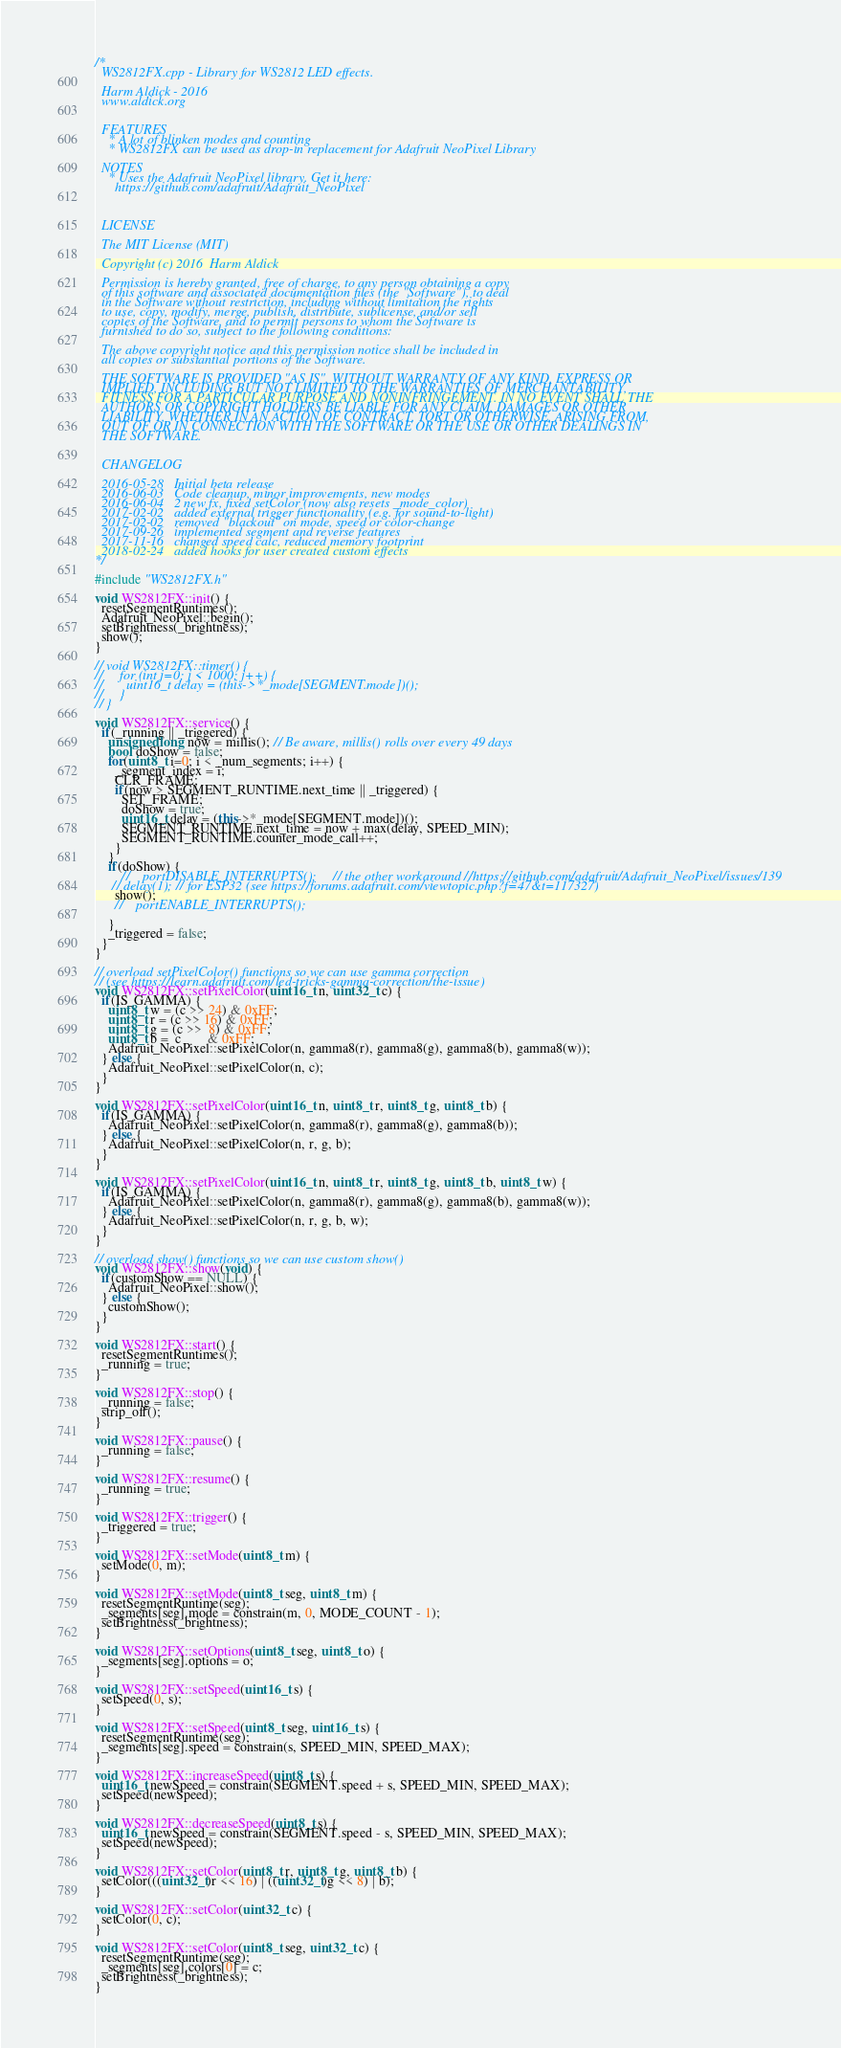<code> <loc_0><loc_0><loc_500><loc_500><_C++_>/*
  WS2812FX.cpp - Library for WS2812 LED effects.

  Harm Aldick - 2016
  www.aldick.org


  FEATURES
    * A lot of blinken modes and counting
    * WS2812FX can be used as drop-in replacement for Adafruit NeoPixel Library

  NOTES
    * Uses the Adafruit NeoPixel library. Get it here:
      https://github.com/adafruit/Adafruit_NeoPixel



  LICENSE

  The MIT License (MIT)

  Copyright (c) 2016  Harm Aldick

  Permission is hereby granted, free of charge, to any person obtaining a copy
  of this software and associated documentation files (the "Software"), to deal
  in the Software without restriction, including without limitation the rights
  to use, copy, modify, merge, publish, distribute, sublicense, and/or sell
  copies of the Software, and to permit persons to whom the Software is
  furnished to do so, subject to the following conditions:

  The above copyright notice and this permission notice shall be included in
  all copies or substantial portions of the Software.

  THE SOFTWARE IS PROVIDED "AS IS", WITHOUT WARRANTY OF ANY KIND, EXPRESS OR
  IMPLIED, INCLUDING BUT NOT LIMITED TO THE WARRANTIES OF MERCHANTABILITY,
  FITNESS FOR A PARTICULAR PURPOSE AND NONINFRINGEMENT. IN NO EVENT SHALL THE
  AUTHORS OR COPYRIGHT HOLDERS BE LIABLE FOR ANY CLAIM, DAMAGES OR OTHER
  LIABILITY, WHETHER IN AN ACTION OF CONTRACT, TORT OR OTHERWISE, ARISING FROM,
  OUT OF OR IN CONNECTION WITH THE SOFTWARE OR THE USE OR OTHER DEALINGS IN
  THE SOFTWARE.


  CHANGELOG

  2016-05-28   Initial beta release
  2016-06-03   Code cleanup, minor improvements, new modes
  2016-06-04   2 new fx, fixed setColor (now also resets _mode_color)
  2017-02-02   added external trigger functionality (e.g. for sound-to-light)
  2017-02-02   removed "blackout" on mode, speed or color-change
  2017-09-26   implemented segment and reverse features
  2017-11-16   changed speed calc, reduced memory footprint
  2018-02-24   added hooks for user created custom effects
*/

#include "WS2812FX.h"

void WS2812FX::init() {
  resetSegmentRuntimes();
  Adafruit_NeoPixel::begin();
  setBrightness(_brightness);
  show();
}

// void WS2812FX::timer() {
//     for (int j=0; j < 1000; j++) {
//       uint16_t delay = (this->*_mode[SEGMENT.mode])();
//     }
// }

void WS2812FX::service() {
  if(_running || _triggered) {
    unsigned long now = millis(); // Be aware, millis() rolls over every 49 days
    bool doShow = false;
    for(uint8_t i=0; i < _num_segments; i++) {
      _segment_index = i;
      CLR_FRAME;
      if(now > SEGMENT_RUNTIME.next_time || _triggered) {
        SET_FRAME;
        doShow = true;
        uint16_t delay = (this->*_mode[SEGMENT.mode])();
        SEGMENT_RUNTIME.next_time = now + max(delay, SPEED_MIN);
        SEGMENT_RUNTIME.counter_mode_call++;
      }
    }
    if(doShow) {
		//    portDISABLE_INTERRUPTS();     // the other workaround //https://github.com/adafruit/Adafruit_NeoPixel/issues/139
     // delay(1); // for ESP32 (see https://forums.adafruit.com/viewtopic.php?f=47&t=117327)
      show();
	  //    portENABLE_INTERRUPTS();
    
    }
    _triggered = false;
  }
}

// overload setPixelColor() functions so we can use gamma correction
// (see https://learn.adafruit.com/led-tricks-gamma-correction/the-issue)
void WS2812FX::setPixelColor(uint16_t n, uint32_t c) {
  if(IS_GAMMA) {
    uint8_t w = (c >> 24) & 0xFF;
    uint8_t r = (c >> 16) & 0xFF;
    uint8_t g = (c >>  8) & 0xFF;
    uint8_t b =  c        & 0xFF;
    Adafruit_NeoPixel::setPixelColor(n, gamma8(r), gamma8(g), gamma8(b), gamma8(w));
  } else {
    Adafruit_NeoPixel::setPixelColor(n, c);
  }
}

void WS2812FX::setPixelColor(uint16_t n, uint8_t r, uint8_t g, uint8_t b) {
  if(IS_GAMMA) {
    Adafruit_NeoPixel::setPixelColor(n, gamma8(r), gamma8(g), gamma8(b));
  } else {
    Adafruit_NeoPixel::setPixelColor(n, r, g, b);
  }
}

void WS2812FX::setPixelColor(uint16_t n, uint8_t r, uint8_t g, uint8_t b, uint8_t w) {
  if(IS_GAMMA) {
    Adafruit_NeoPixel::setPixelColor(n, gamma8(r), gamma8(g), gamma8(b), gamma8(w));
  } else {
    Adafruit_NeoPixel::setPixelColor(n, r, g, b, w);
  }
}

// overload show() functions so we can use custom show()
void WS2812FX::show(void) {
  if(customShow == NULL) {
    Adafruit_NeoPixel::show();
  } else {
    customShow();
  }
}

void WS2812FX::start() {
  resetSegmentRuntimes();
  _running = true;
}

void WS2812FX::stop() {
  _running = false;
  strip_off();
}

void WS2812FX::pause() {
  _running = false;
}

void WS2812FX::resume() {
  _running = true;
}

void WS2812FX::trigger() {
  _triggered = true;
}

void WS2812FX::setMode(uint8_t m) {
  setMode(0, m);
}

void WS2812FX::setMode(uint8_t seg, uint8_t m) {
  resetSegmentRuntime(seg);
  _segments[seg].mode = constrain(m, 0, MODE_COUNT - 1);
  setBrightness(_brightness);
}

void WS2812FX::setOptions(uint8_t seg, uint8_t o) {
  _segments[seg].options = o;
}

void WS2812FX::setSpeed(uint16_t s) {
  setSpeed(0, s);
}

void WS2812FX::setSpeed(uint8_t seg, uint16_t s) {
  resetSegmentRuntime(seg);
  _segments[seg].speed = constrain(s, SPEED_MIN, SPEED_MAX);
}

void WS2812FX::increaseSpeed(uint8_t s) {
  uint16_t newSpeed = constrain(SEGMENT.speed + s, SPEED_MIN, SPEED_MAX);
  setSpeed(newSpeed);
}

void WS2812FX::decreaseSpeed(uint8_t s) {
  uint16_t newSpeed = constrain(SEGMENT.speed - s, SPEED_MIN, SPEED_MAX);
  setSpeed(newSpeed);
}

void WS2812FX::setColor(uint8_t r, uint8_t g, uint8_t b) {
  setColor(((uint32_t)r << 16) | ((uint32_t)g << 8) | b);
}

void WS2812FX::setColor(uint32_t c) {
  setColor(0, c);
}

void WS2812FX::setColor(uint8_t seg, uint32_t c) {
  resetSegmentRuntime(seg);
  _segments[seg].colors[0] = c;
  setBrightness(_brightness);
}
</code> 